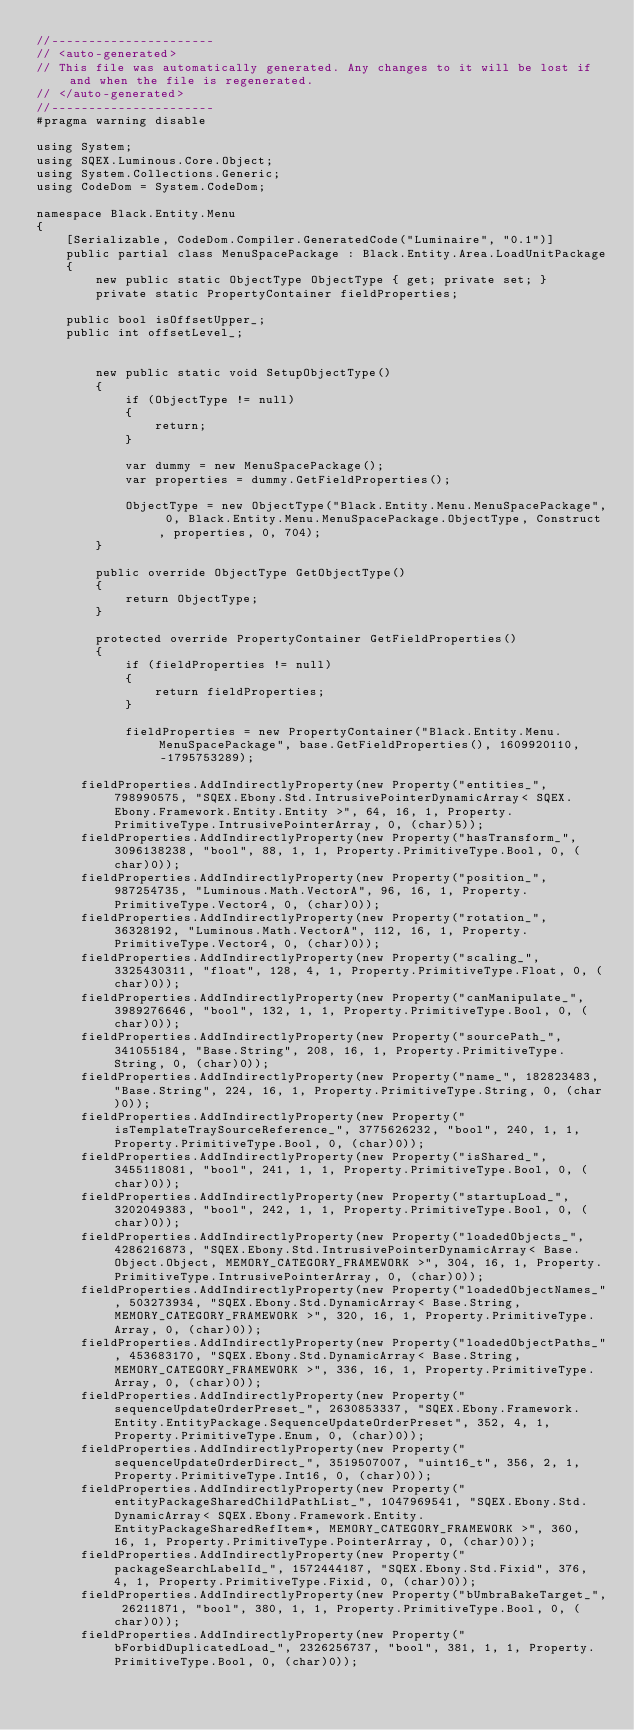Convert code to text. <code><loc_0><loc_0><loc_500><loc_500><_C#_>//----------------------
// <auto-generated>
// This file was automatically generated. Any changes to it will be lost if and when the file is regenerated.
// </auto-generated>
//----------------------
#pragma warning disable

using System;
using SQEX.Luminous.Core.Object;
using System.Collections.Generic;
using CodeDom = System.CodeDom;

namespace Black.Entity.Menu
{
    [Serializable, CodeDom.Compiler.GeneratedCode("Luminaire", "0.1")]
    public partial class MenuSpacePackage : Black.Entity.Area.LoadUnitPackage
    {
        new public static ObjectType ObjectType { get; private set; }
        private static PropertyContainer fieldProperties;
		
		public bool isOffsetUpper_;
		public int offsetLevel_;
		
        
        new public static void SetupObjectType()
        {
            if (ObjectType != null)
            {
                return;
            }

            var dummy = new MenuSpacePackage();
            var properties = dummy.GetFieldProperties();

            ObjectType = new ObjectType("Black.Entity.Menu.MenuSpacePackage", 0, Black.Entity.Menu.MenuSpacePackage.ObjectType, Construct, properties, 0, 704);
        }
		
        public override ObjectType GetObjectType()
        {
            return ObjectType;
        }

        protected override PropertyContainer GetFieldProperties()
        {
            if (fieldProperties != null)
            {
                return fieldProperties;
            }

            fieldProperties = new PropertyContainer("Black.Entity.Menu.MenuSpacePackage", base.GetFieldProperties(), 1609920110, -1795753289);
            
			fieldProperties.AddIndirectlyProperty(new Property("entities_", 798990575, "SQEX.Ebony.Std.IntrusivePointerDynamicArray< SQEX.Ebony.Framework.Entity.Entity >", 64, 16, 1, Property.PrimitiveType.IntrusivePointerArray, 0, (char)5));
			fieldProperties.AddIndirectlyProperty(new Property("hasTransform_", 3096138238, "bool", 88, 1, 1, Property.PrimitiveType.Bool, 0, (char)0));
			fieldProperties.AddIndirectlyProperty(new Property("position_", 987254735, "Luminous.Math.VectorA", 96, 16, 1, Property.PrimitiveType.Vector4, 0, (char)0));
			fieldProperties.AddIndirectlyProperty(new Property("rotation_", 36328192, "Luminous.Math.VectorA", 112, 16, 1, Property.PrimitiveType.Vector4, 0, (char)0));
			fieldProperties.AddIndirectlyProperty(new Property("scaling_", 3325430311, "float", 128, 4, 1, Property.PrimitiveType.Float, 0, (char)0));
			fieldProperties.AddIndirectlyProperty(new Property("canManipulate_", 3989276646, "bool", 132, 1, 1, Property.PrimitiveType.Bool, 0, (char)0));
			fieldProperties.AddIndirectlyProperty(new Property("sourcePath_", 341055184, "Base.String", 208, 16, 1, Property.PrimitiveType.String, 0, (char)0));
			fieldProperties.AddIndirectlyProperty(new Property("name_", 182823483, "Base.String", 224, 16, 1, Property.PrimitiveType.String, 0, (char)0));
			fieldProperties.AddIndirectlyProperty(new Property("isTemplateTraySourceReference_", 3775626232, "bool", 240, 1, 1, Property.PrimitiveType.Bool, 0, (char)0));
			fieldProperties.AddIndirectlyProperty(new Property("isShared_", 3455118081, "bool", 241, 1, 1, Property.PrimitiveType.Bool, 0, (char)0));
			fieldProperties.AddIndirectlyProperty(new Property("startupLoad_", 3202049383, "bool", 242, 1, 1, Property.PrimitiveType.Bool, 0, (char)0));
			fieldProperties.AddIndirectlyProperty(new Property("loadedObjects_", 4286216873, "SQEX.Ebony.Std.IntrusivePointerDynamicArray< Base.Object.Object, MEMORY_CATEGORY_FRAMEWORK >", 304, 16, 1, Property.PrimitiveType.IntrusivePointerArray, 0, (char)0));
			fieldProperties.AddIndirectlyProperty(new Property("loadedObjectNames_", 503273934, "SQEX.Ebony.Std.DynamicArray< Base.String, MEMORY_CATEGORY_FRAMEWORK >", 320, 16, 1, Property.PrimitiveType.Array, 0, (char)0));
			fieldProperties.AddIndirectlyProperty(new Property("loadedObjectPaths_", 453683170, "SQEX.Ebony.Std.DynamicArray< Base.String, MEMORY_CATEGORY_FRAMEWORK >", 336, 16, 1, Property.PrimitiveType.Array, 0, (char)0));
			fieldProperties.AddIndirectlyProperty(new Property("sequenceUpdateOrderPreset_", 2630853337, "SQEX.Ebony.Framework.Entity.EntityPackage.SequenceUpdateOrderPreset", 352, 4, 1, Property.PrimitiveType.Enum, 0, (char)0));
			fieldProperties.AddIndirectlyProperty(new Property("sequenceUpdateOrderDirect_", 3519507007, "uint16_t", 356, 2, 1, Property.PrimitiveType.Int16, 0, (char)0));
			fieldProperties.AddIndirectlyProperty(new Property("entityPackageSharedChildPathList_", 1047969541, "SQEX.Ebony.Std.DynamicArray< SQEX.Ebony.Framework.Entity.EntityPackageSharedRefItem*, MEMORY_CATEGORY_FRAMEWORK >", 360, 16, 1, Property.PrimitiveType.PointerArray, 0, (char)0));
			fieldProperties.AddIndirectlyProperty(new Property("packageSearchLabelId_", 1572444187, "SQEX.Ebony.Std.Fixid", 376, 4, 1, Property.PrimitiveType.Fixid, 0, (char)0));
			fieldProperties.AddIndirectlyProperty(new Property("bUmbraBakeTarget_", 26211871, "bool", 380, 1, 1, Property.PrimitiveType.Bool, 0, (char)0));
			fieldProperties.AddIndirectlyProperty(new Property("bForbidDuplicatedLoad_", 2326256737, "bool", 381, 1, 1, Property.PrimitiveType.Bool, 0, (char)0));</code> 